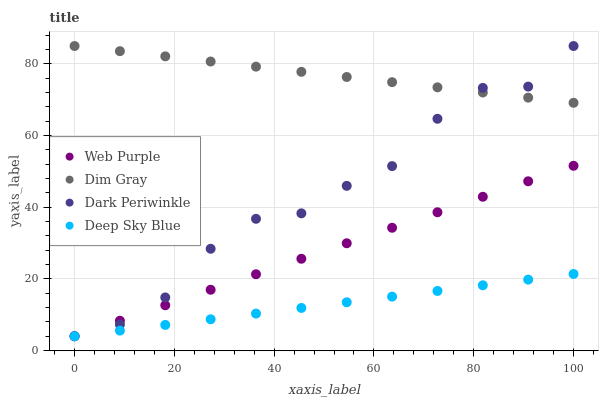Does Deep Sky Blue have the minimum area under the curve?
Answer yes or no. Yes. Does Dim Gray have the maximum area under the curve?
Answer yes or no. Yes. Does Dark Periwinkle have the minimum area under the curve?
Answer yes or no. No. Does Dark Periwinkle have the maximum area under the curve?
Answer yes or no. No. Is Deep Sky Blue the smoothest?
Answer yes or no. Yes. Is Dark Periwinkle the roughest?
Answer yes or no. Yes. Is Dim Gray the smoothest?
Answer yes or no. No. Is Dim Gray the roughest?
Answer yes or no. No. Does Web Purple have the lowest value?
Answer yes or no. Yes. Does Dim Gray have the lowest value?
Answer yes or no. No. Does Dark Periwinkle have the highest value?
Answer yes or no. Yes. Does Deep Sky Blue have the highest value?
Answer yes or no. No. Is Deep Sky Blue less than Dim Gray?
Answer yes or no. Yes. Is Dim Gray greater than Deep Sky Blue?
Answer yes or no. Yes. Does Dark Periwinkle intersect Deep Sky Blue?
Answer yes or no. Yes. Is Dark Periwinkle less than Deep Sky Blue?
Answer yes or no. No. Is Dark Periwinkle greater than Deep Sky Blue?
Answer yes or no. No. Does Deep Sky Blue intersect Dim Gray?
Answer yes or no. No. 